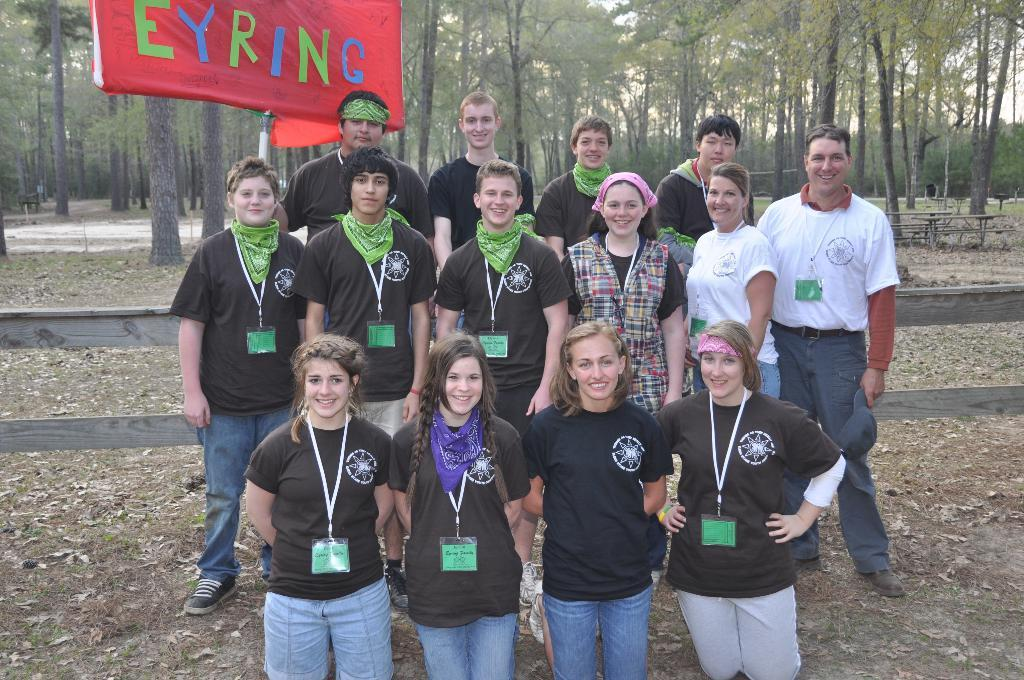How many people are in the image? There is a group of people in the image, but the exact number is not specified. What can be observed about the clothing of the people in the image? The people are wearing different dress. What is in the background of the image? There is a red color board and trees visible in the background. Are there any structures or objects in the background? Yes, there are benches in the background. What type of blade is being used by the people in the image? There is no blade present in the image; the people are simply wearing different dress. How does the hope of the people in the image manifest itself? The image does not provide any information about the hopes or emotions of the people, so it cannot be determined from the image. 